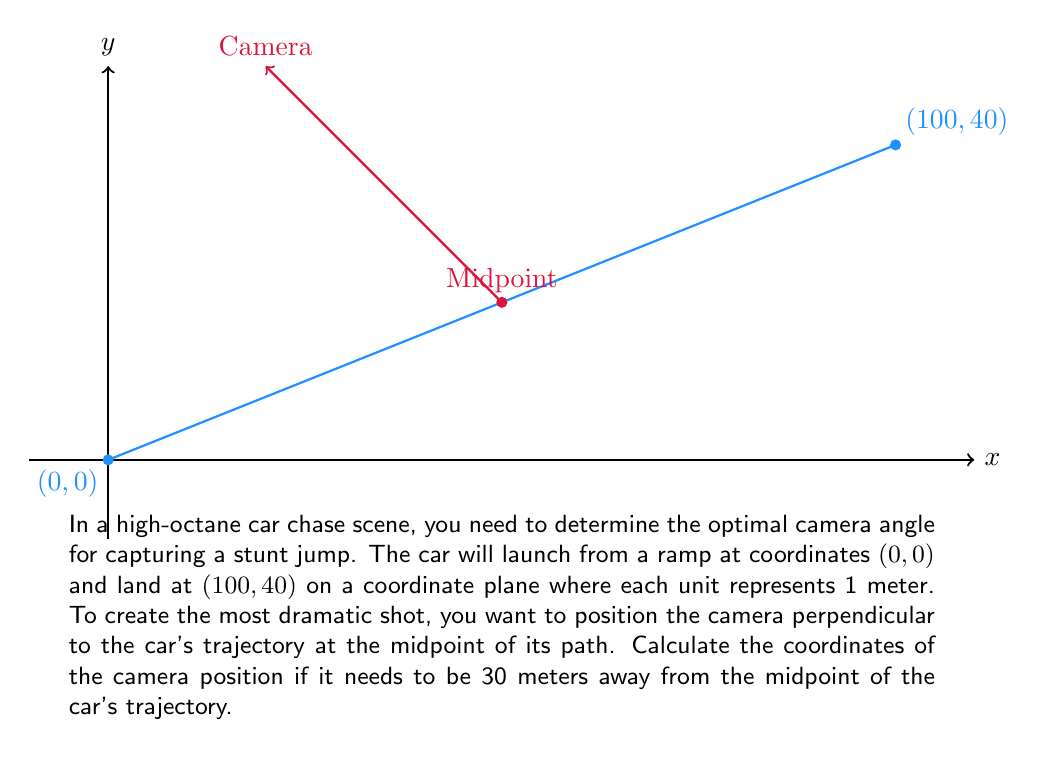Could you help me with this problem? Let's approach this step-by-step:

1) First, we need to find the midpoint of the car's trajectory. The midpoint formula is:
   $$(\frac{x_1 + x_2}{2}, \frac{y_1 + y_2}{2})$$

   Where $(x_1, y_1)$ is (0, 0) and $(x_2, y_2)$ is (100, 40).

2) Plugging in the values:
   $$(\frac{0 + 100}{2}, \frac{0 + 40}{2}) = (50, 20)$$

3) Now, we need to find a vector perpendicular to the car's trajectory. The trajectory vector is:
   $$(100 - 0, 40 - 0) = (100, 40)$$

4) To get a perpendicular vector, we can swap the x and y components and negate one:
   $$(-40, 100)$$ or $$(40, -100)$$
   Let's use $(-40, 100)$ for this problem.

5) We need to normalize this vector (make its length 1):
   Length = $\sqrt{(-40)^2 + 100^2} = \sqrt{1600 + 10000} = \sqrt{11600} \approx 107.70$
   
   Normalized vector: $$(\frac{-40}{107.70}, \frac{100}{107.70}) \approx (-0.3713, 0.9283)$$

6) Now, we multiply this normalized vector by 30 (the distance we want the camera):
   $$30 * (-0.3713, 0.9283) \approx (-11.14, 27.85)$$

7) Finally, we add this to the midpoint coordinates:
   $$(50 - 11.14, 20 + 27.85) \approx (38.86, 47.85)$$
Answer: (38.86, 47.85) 